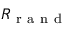Convert formula to latex. <formula><loc_0><loc_0><loc_500><loc_500>R _ { r a n d }</formula> 